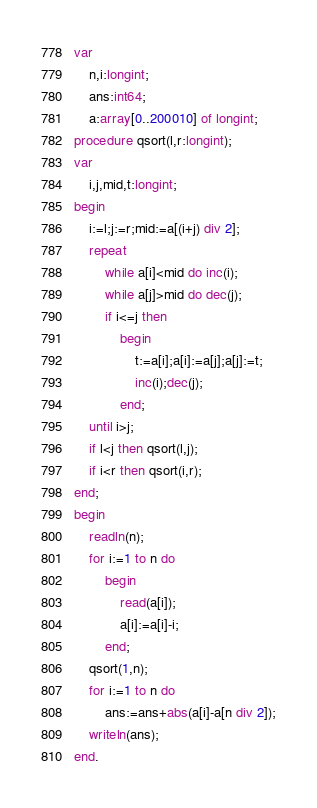Convert code to text. <code><loc_0><loc_0><loc_500><loc_500><_Pascal_>var
    n,i:longint;
    ans:int64;
    a:array[0..200010] of longint;
procedure qsort(l,r:longint);
var
    i,j,mid,t:longint;
begin
    i:=l;j:=r;mid:=a[(i+j) div 2];
    repeat
        while a[i]<mid do inc(i);
        while a[j]>mid do dec(j);
        if i<=j then 
            begin
                t:=a[i];a[i]:=a[j];a[j]:=t;
                inc(i);dec(j);
            end;
    until i>j;
    if l<j then qsort(l,j);
    if i<r then qsort(i,r);
end;
begin
    readln(n);
    for i:=1 to n do
        begin
            read(a[i]);
            a[i]:=a[i]-i;
        end;
    qsort(1,n);
    for i:=1 to n do
        ans:=ans+abs(a[i]-a[n div 2]);
    writeln(ans);
end. </code> 